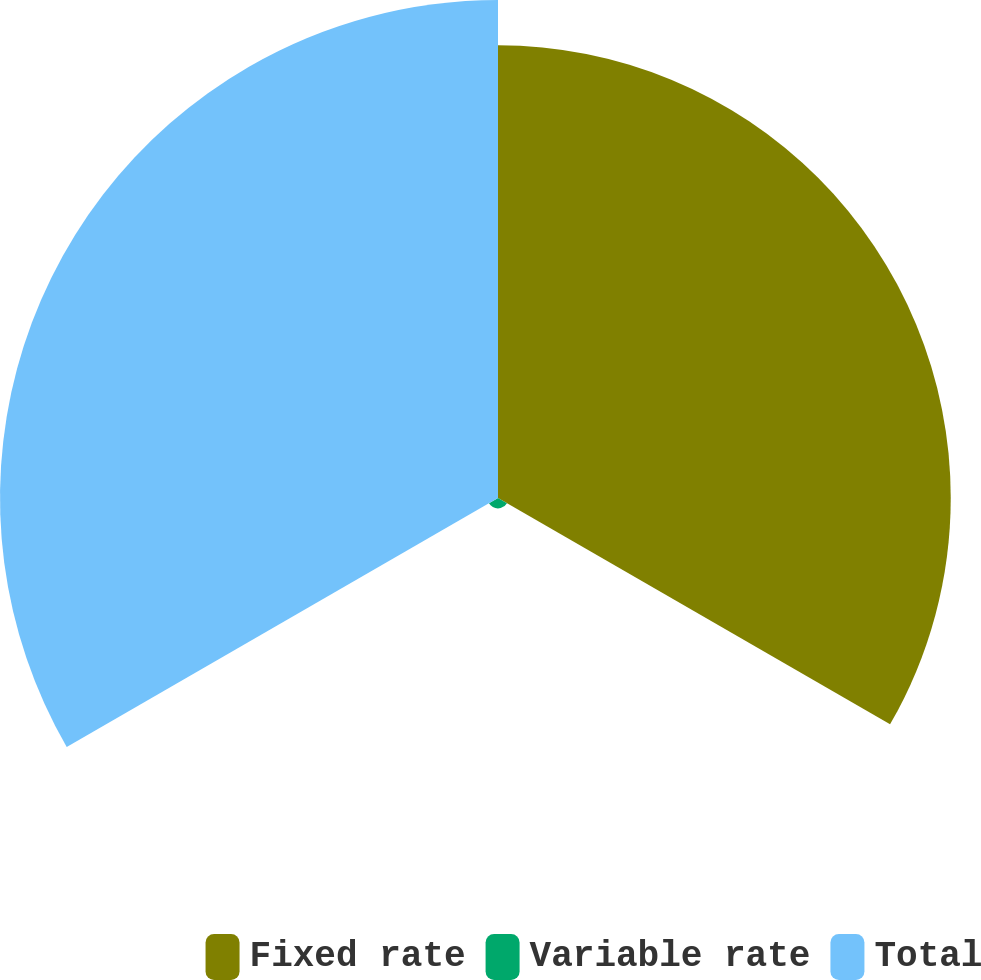Convert chart. <chart><loc_0><loc_0><loc_500><loc_500><pie_chart><fcel>Fixed rate<fcel>Variable rate<fcel>Total<nl><fcel>47.11%<fcel>1.08%<fcel>51.82%<nl></chart> 